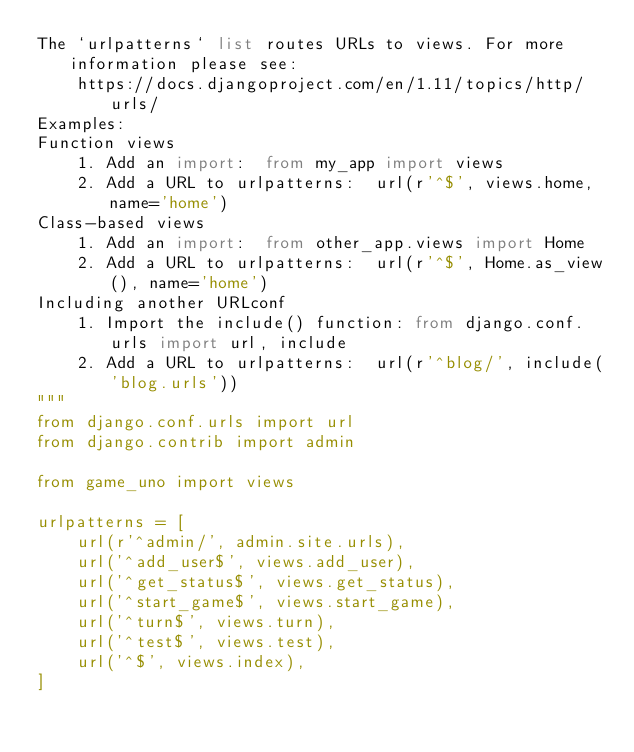<code> <loc_0><loc_0><loc_500><loc_500><_Python_>The `urlpatterns` list routes URLs to views. For more information please see:
    https://docs.djangoproject.com/en/1.11/topics/http/urls/
Examples:
Function views
    1. Add an import:  from my_app import views
    2. Add a URL to urlpatterns:  url(r'^$', views.home, name='home')
Class-based views
    1. Add an import:  from other_app.views import Home
    2. Add a URL to urlpatterns:  url(r'^$', Home.as_view(), name='home')
Including another URLconf
    1. Import the include() function: from django.conf.urls import url, include
    2. Add a URL to urlpatterns:  url(r'^blog/', include('blog.urls'))
"""
from django.conf.urls import url
from django.contrib import admin

from game_uno import views

urlpatterns = [
    url(r'^admin/', admin.site.urls),
    url('^add_user$', views.add_user),
    url('^get_status$', views.get_status),
    url('^start_game$', views.start_game),
    url('^turn$', views.turn),
    url('^test$', views.test),
    url('^$', views.index),
]
</code> 